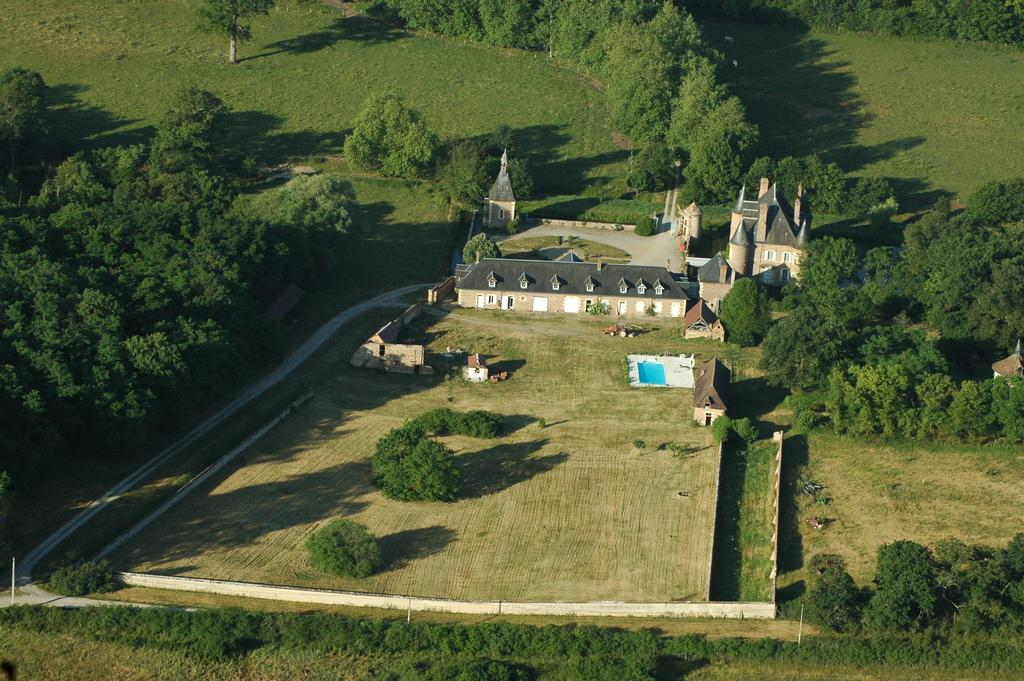What perspective is the image taken from? The image is taken from a top view. What is the main feature at the center of the image? There is a building with a swimming pool at the center of the image. What type of vegetation surrounds the building? The building is surrounded by trees, plants, and grass. What creature is talking to the building in the image? There is no creature present in the image, and the building is not capable of talking. 